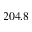Convert formula to latex. <formula><loc_0><loc_0><loc_500><loc_500>2 0 4 . 8</formula> 